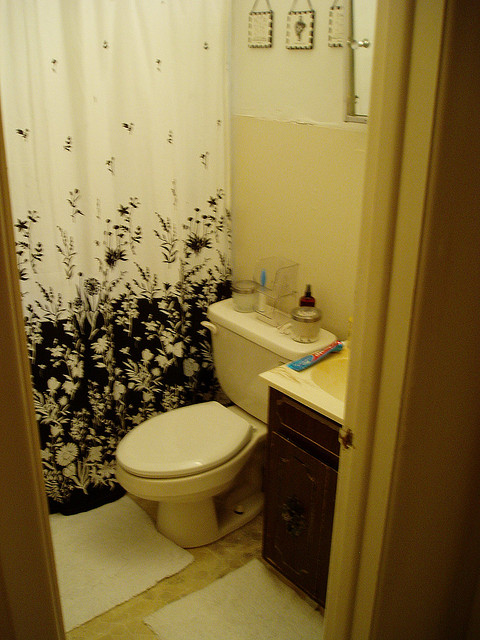Please identify all text content in this image. Colgate 